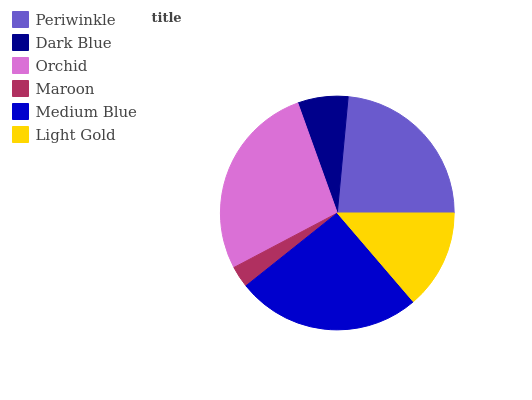Is Maroon the minimum?
Answer yes or no. Yes. Is Orchid the maximum?
Answer yes or no. Yes. Is Dark Blue the minimum?
Answer yes or no. No. Is Dark Blue the maximum?
Answer yes or no. No. Is Periwinkle greater than Dark Blue?
Answer yes or no. Yes. Is Dark Blue less than Periwinkle?
Answer yes or no. Yes. Is Dark Blue greater than Periwinkle?
Answer yes or no. No. Is Periwinkle less than Dark Blue?
Answer yes or no. No. Is Periwinkle the high median?
Answer yes or no. Yes. Is Light Gold the low median?
Answer yes or no. Yes. Is Light Gold the high median?
Answer yes or no. No. Is Medium Blue the low median?
Answer yes or no. No. 